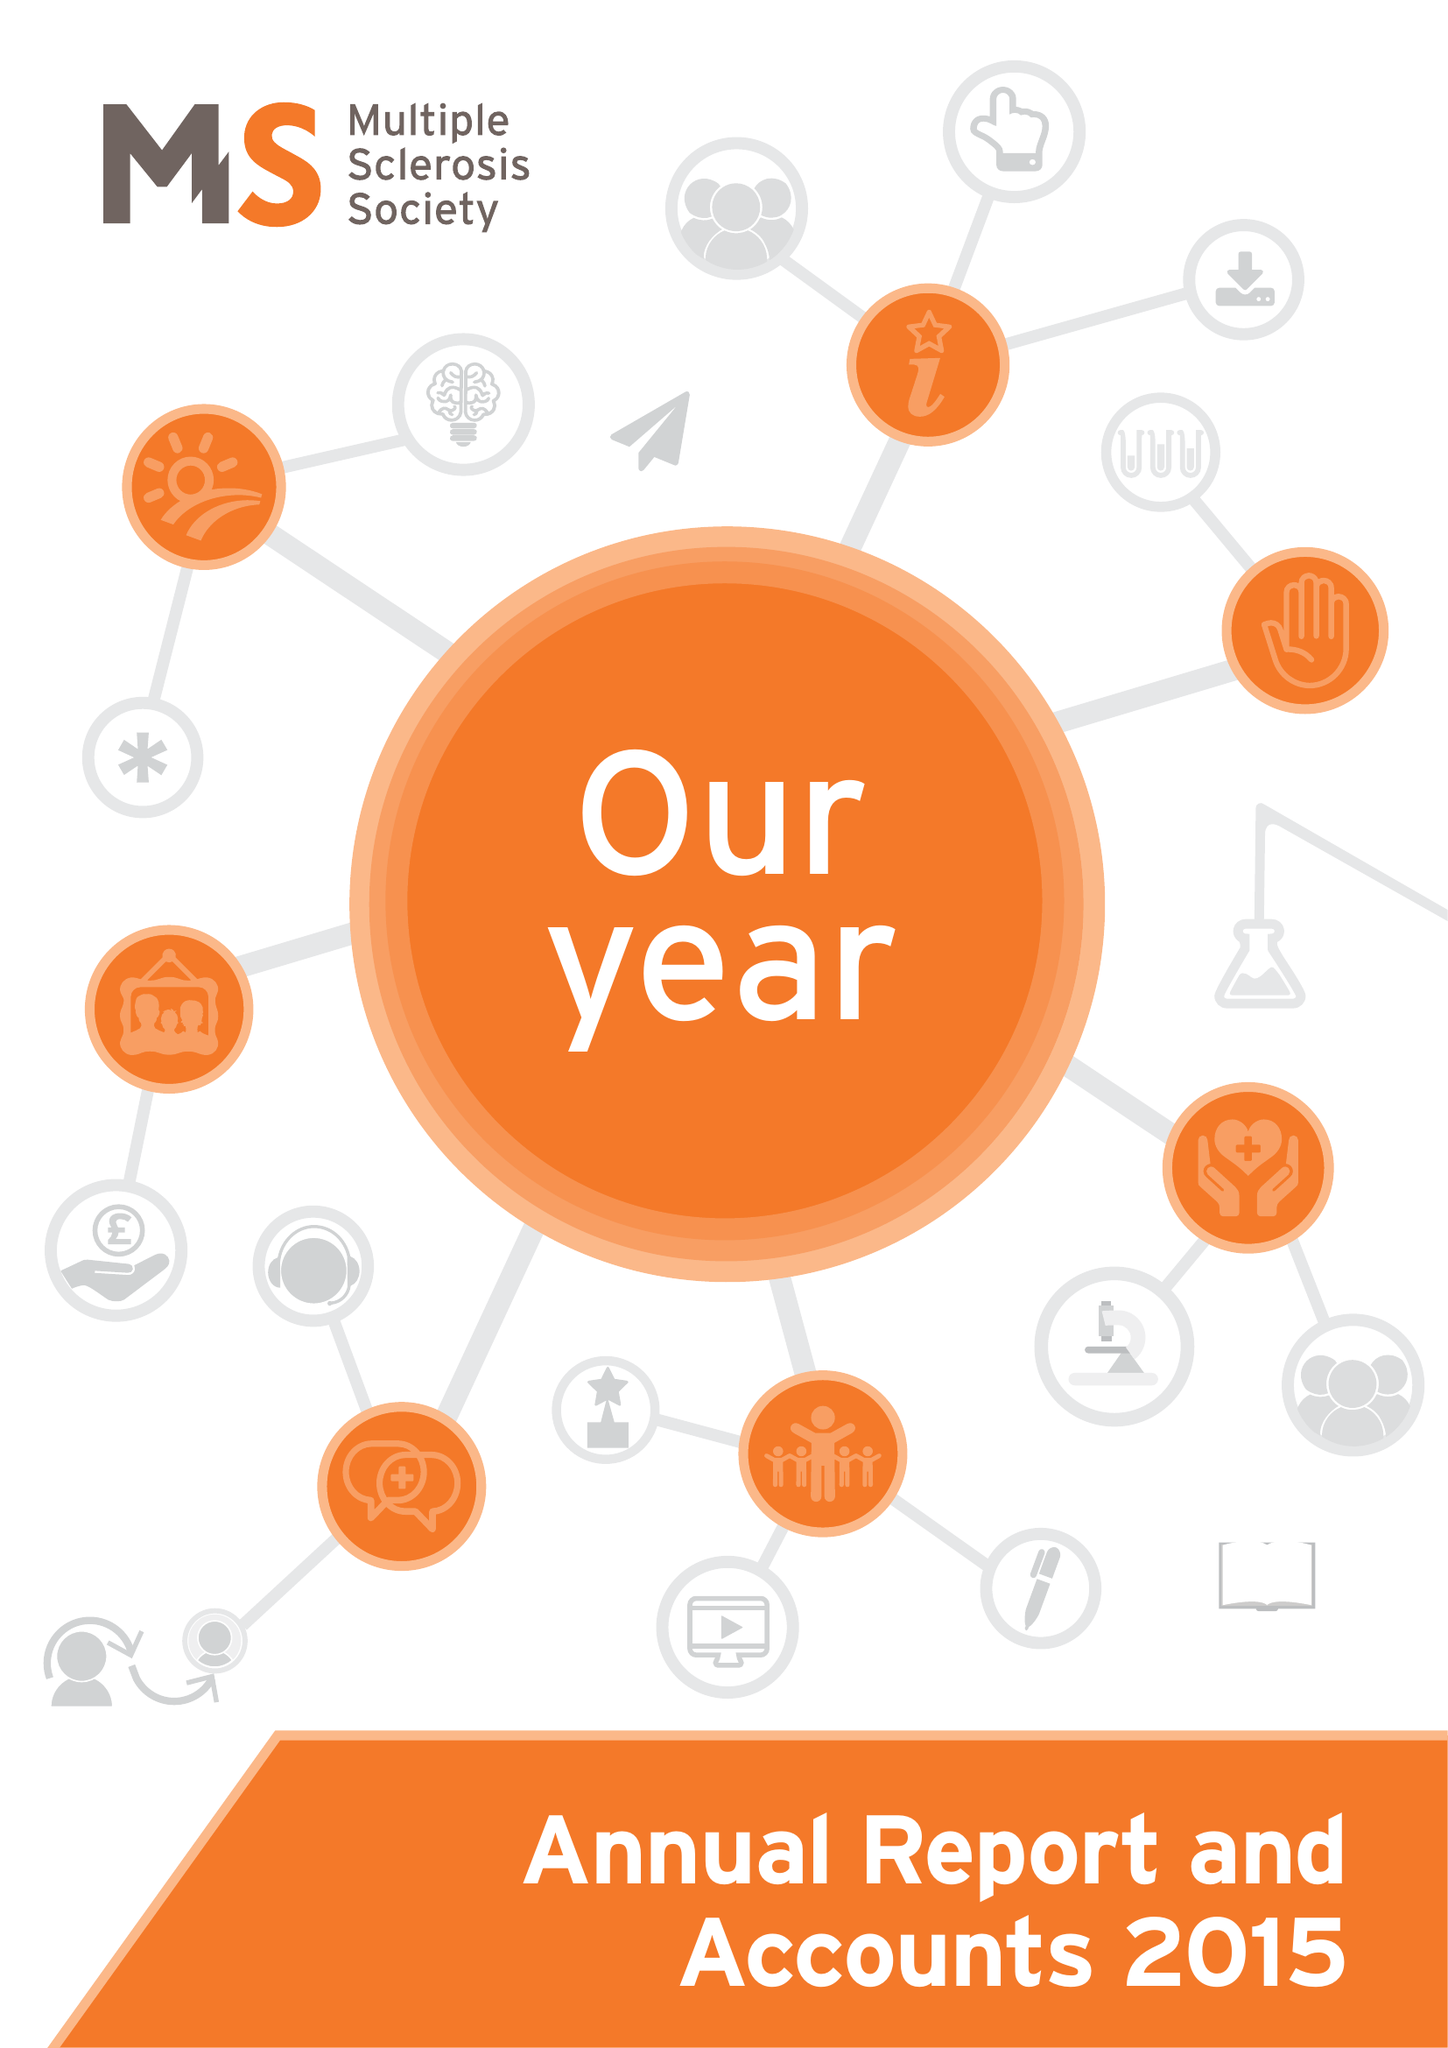What is the value for the address__postcode?
Answer the question using a single word or phrase. NW2 6ND 